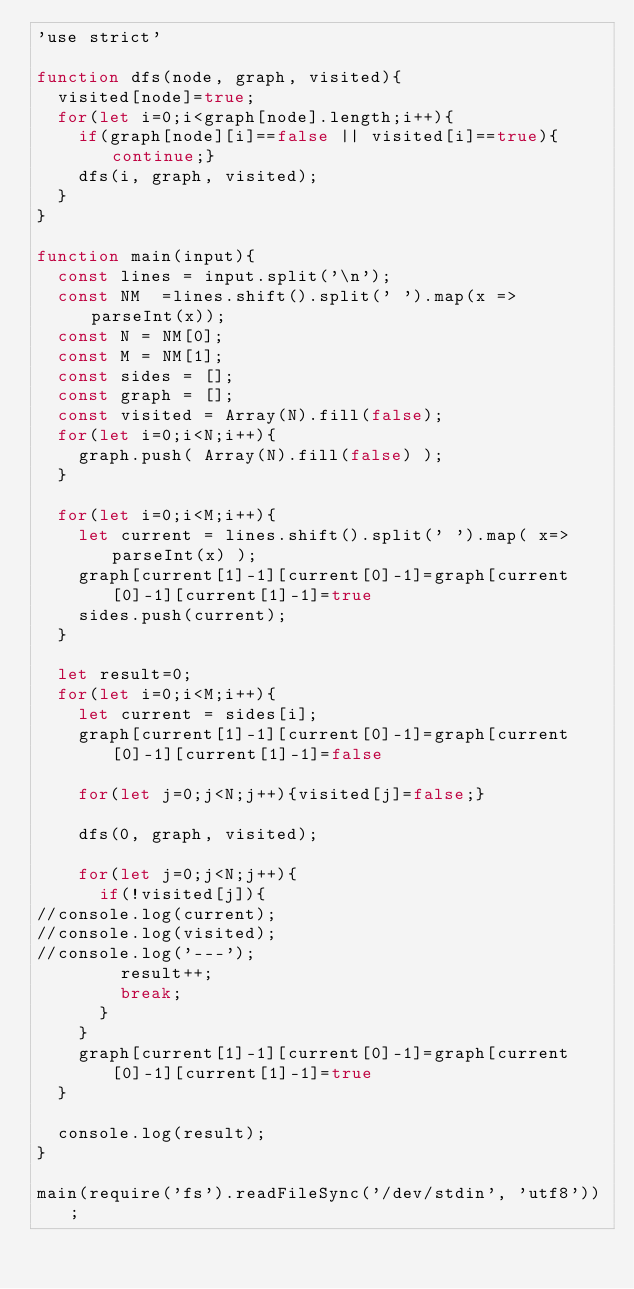<code> <loc_0><loc_0><loc_500><loc_500><_JavaScript_>'use strict'

function dfs(node, graph, visited){
  visited[node]=true;
  for(let i=0;i<graph[node].length;i++){
    if(graph[node][i]==false || visited[i]==true){continue;}
    dfs(i, graph, visited);
  }
}

function main(input){
  const lines = input.split('\n');
  const NM  =lines.shift().split(' ').map(x => parseInt(x));
  const N = NM[0];
  const M = NM[1];
  const sides = [];
  const graph = [];
  const visited = Array(N).fill(false);
  for(let i=0;i<N;i++){
    graph.push( Array(N).fill(false) );
  }

  for(let i=0;i<M;i++){
    let current = lines.shift().split(' ').map( x=>parseInt(x) );
    graph[current[1]-1][current[0]-1]=graph[current[0]-1][current[1]-1]=true
    sides.push(current);
  }

  let result=0;
  for(let i=0;i<M;i++){
    let current = sides[i];
    graph[current[1]-1][current[0]-1]=graph[current[0]-1][current[1]-1]=false

    for(let j=0;j<N;j++){visited[j]=false;}

    dfs(0, graph, visited);

    for(let j=0;j<N;j++){
      if(!visited[j]){
//console.log(current);
//console.log(visited);
//console.log('---');
        result++;
        break;
      }
    }
    graph[current[1]-1][current[0]-1]=graph[current[0]-1][current[1]-1]=true
  }

  console.log(result);
}

main(require('fs').readFileSync('/dev/stdin', 'utf8'));
</code> 